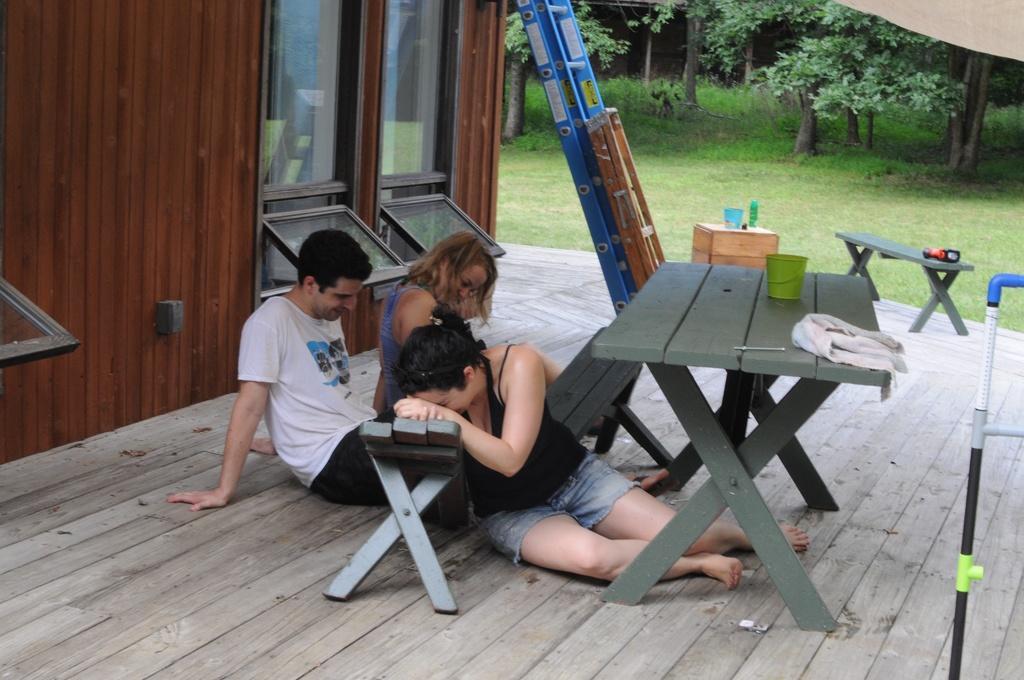Could you give a brief overview of what you see in this image? In this image I see a man and 2 women sitting on the floor and there is a table in front and there is a glass and cloth on it. In the background I see the grass and the trees. 